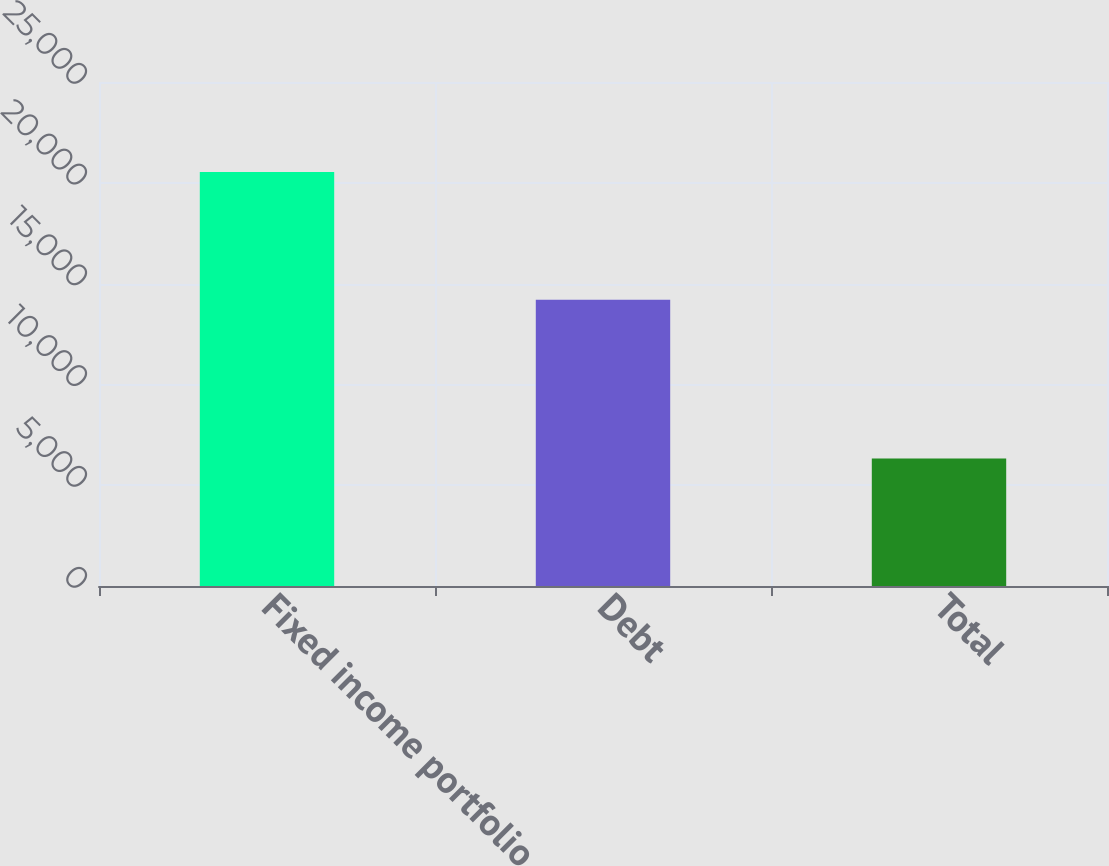Convert chart. <chart><loc_0><loc_0><loc_500><loc_500><bar_chart><fcel>Fixed income portfolio<fcel>Debt<fcel>Total<nl><fcel>20530<fcel>14200<fcel>6330<nl></chart> 